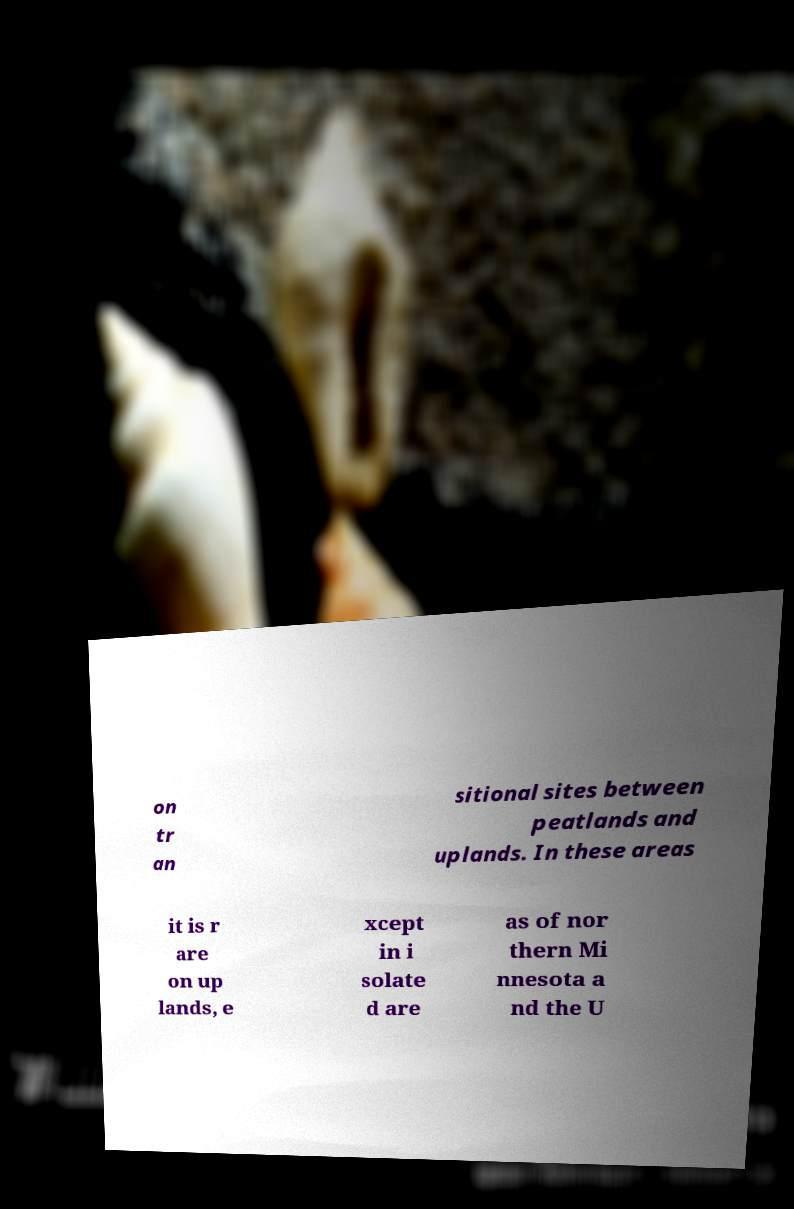Please identify and transcribe the text found in this image. on tr an sitional sites between peatlands and uplands. In these areas it is r are on up lands, e xcept in i solate d are as of nor thern Mi nnesota a nd the U 